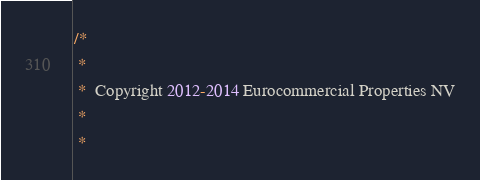Convert code to text. <code><loc_0><loc_0><loc_500><loc_500><_Java_>/*
 *
 *  Copyright 2012-2014 Eurocommercial Properties NV
 *
 *</code> 